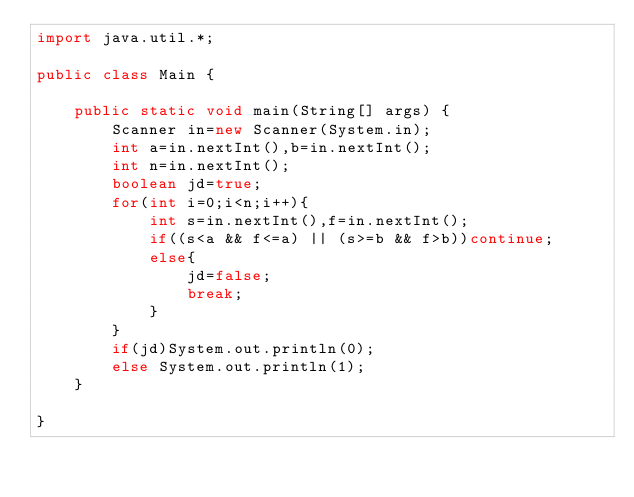Convert code to text. <code><loc_0><loc_0><loc_500><loc_500><_Java_>import java.util.*;

public class Main {

	public static void main(String[] args) {
		Scanner in=new Scanner(System.in);
		int a=in.nextInt(),b=in.nextInt();
		int n=in.nextInt();
		boolean jd=true;
		for(int i=0;i<n;i++){
			int s=in.nextInt(),f=in.nextInt();
			if((s<a && f<=a) || (s>=b && f>b))continue;
			else{
				jd=false;
				break;
			}
		}
		if(jd)System.out.println(0);
		else System.out.println(1);
	}

}

</code> 